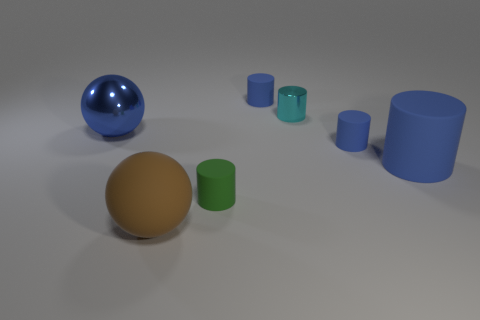How many large objects are to the right of the large blue thing that is behind the big blue matte cylinder?
Provide a succinct answer. 2. The matte object that is both behind the big cylinder and on the left side of the tiny cyan metal object has what shape?
Provide a succinct answer. Cylinder. How many rubber cylinders are the same color as the metallic cylinder?
Your response must be concise. 0. Is there a metal cylinder in front of the shiny object to the left of the sphere in front of the blue sphere?
Provide a succinct answer. No. How big is the cylinder that is both to the left of the small cyan metallic cylinder and behind the green cylinder?
Your answer should be very brief. Small. How many small green cubes are made of the same material as the brown ball?
Give a very brief answer. 0. What number of cylinders are big brown matte objects or big things?
Ensure brevity in your answer.  1. There is a blue matte object that is left of the small blue rubber cylinder in front of the shiny object to the left of the cyan metallic thing; how big is it?
Ensure brevity in your answer.  Small. What color is the matte thing that is both in front of the big blue rubber object and on the right side of the big matte ball?
Make the answer very short. Green. Is the size of the brown rubber ball the same as the blue metal thing on the left side of the cyan cylinder?
Give a very brief answer. Yes. 